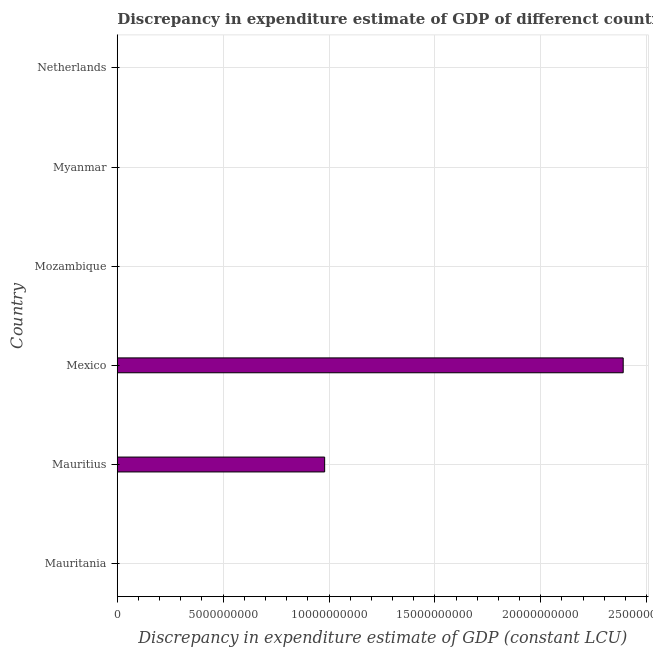Does the graph contain grids?
Your answer should be very brief. Yes. What is the title of the graph?
Provide a short and direct response. Discrepancy in expenditure estimate of GDP of differenct countries in 1980. What is the label or title of the X-axis?
Your answer should be compact. Discrepancy in expenditure estimate of GDP (constant LCU). What is the discrepancy in expenditure estimate of gdp in Mexico?
Offer a very short reply. 2.39e+1. Across all countries, what is the maximum discrepancy in expenditure estimate of gdp?
Provide a short and direct response. 2.39e+1. In which country was the discrepancy in expenditure estimate of gdp maximum?
Make the answer very short. Mexico. What is the sum of the discrepancy in expenditure estimate of gdp?
Provide a succinct answer. 3.37e+1. What is the average discrepancy in expenditure estimate of gdp per country?
Your response must be concise. 5.61e+09. What is the ratio of the discrepancy in expenditure estimate of gdp in Mauritius to that in Mexico?
Ensure brevity in your answer.  0.41. What is the difference between the highest and the lowest discrepancy in expenditure estimate of gdp?
Provide a short and direct response. 2.39e+1. In how many countries, is the discrepancy in expenditure estimate of gdp greater than the average discrepancy in expenditure estimate of gdp taken over all countries?
Offer a very short reply. 2. How many countries are there in the graph?
Keep it short and to the point. 6. What is the Discrepancy in expenditure estimate of GDP (constant LCU) in Mauritania?
Provide a short and direct response. 0. What is the Discrepancy in expenditure estimate of GDP (constant LCU) of Mauritius?
Offer a very short reply. 9.79e+09. What is the Discrepancy in expenditure estimate of GDP (constant LCU) in Mexico?
Make the answer very short. 2.39e+1. What is the Discrepancy in expenditure estimate of GDP (constant LCU) of Mozambique?
Offer a very short reply. 0. What is the difference between the Discrepancy in expenditure estimate of GDP (constant LCU) in Mauritius and Mexico?
Ensure brevity in your answer.  -1.41e+1. What is the ratio of the Discrepancy in expenditure estimate of GDP (constant LCU) in Mauritius to that in Mexico?
Ensure brevity in your answer.  0.41. 